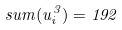<formula> <loc_0><loc_0><loc_500><loc_500>s u m ( u _ { i } ^ { 3 } ) = 1 9 2</formula> 